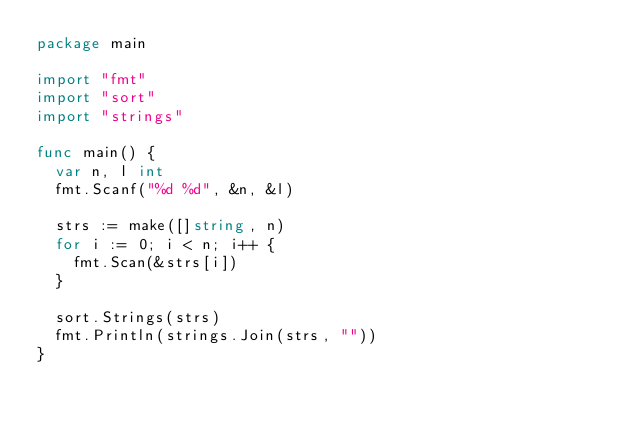<code> <loc_0><loc_0><loc_500><loc_500><_Go_>package main

import "fmt"
import "sort"
import "strings"

func main() {
	var n, l int
	fmt.Scanf("%d %d", &n, &l)

	strs := make([]string, n)
	for i := 0; i < n; i++ {
		fmt.Scan(&strs[i])
	}

	sort.Strings(strs)
	fmt.Println(strings.Join(strs, ""))
}</code> 